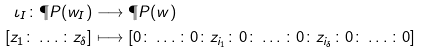<formula> <loc_0><loc_0><loc_500><loc_500>\iota _ { I } \colon \P P ( w _ { I } ) & \longrightarrow \P P ( w ) \\ [ z _ { 1 } \colon \dots \colon z _ { \delta } ] & \longmapsto [ 0 \colon \dots \colon 0 \colon z _ { i _ { 1 } } \colon 0 \colon \dots \colon 0 \colon z _ { i _ { \delta } } \colon 0 \colon \dots \colon 0 ]</formula> 